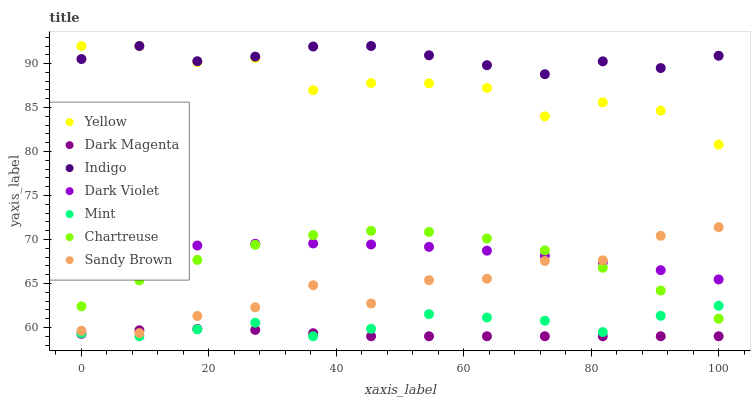Does Dark Magenta have the minimum area under the curve?
Answer yes or no. Yes. Does Indigo have the maximum area under the curve?
Answer yes or no. Yes. Does Sandy Brown have the minimum area under the curve?
Answer yes or no. No. Does Sandy Brown have the maximum area under the curve?
Answer yes or no. No. Is Dark Magenta the smoothest?
Answer yes or no. Yes. Is Yellow the roughest?
Answer yes or no. Yes. Is Sandy Brown the smoothest?
Answer yes or no. No. Is Sandy Brown the roughest?
Answer yes or no. No. Does Dark Magenta have the lowest value?
Answer yes or no. Yes. Does Sandy Brown have the lowest value?
Answer yes or no. No. Does Yellow have the highest value?
Answer yes or no. Yes. Does Sandy Brown have the highest value?
Answer yes or no. No. Is Dark Violet less than Yellow?
Answer yes or no. Yes. Is Indigo greater than Dark Violet?
Answer yes or no. Yes. Does Indigo intersect Yellow?
Answer yes or no. Yes. Is Indigo less than Yellow?
Answer yes or no. No. Is Indigo greater than Yellow?
Answer yes or no. No. Does Dark Violet intersect Yellow?
Answer yes or no. No. 